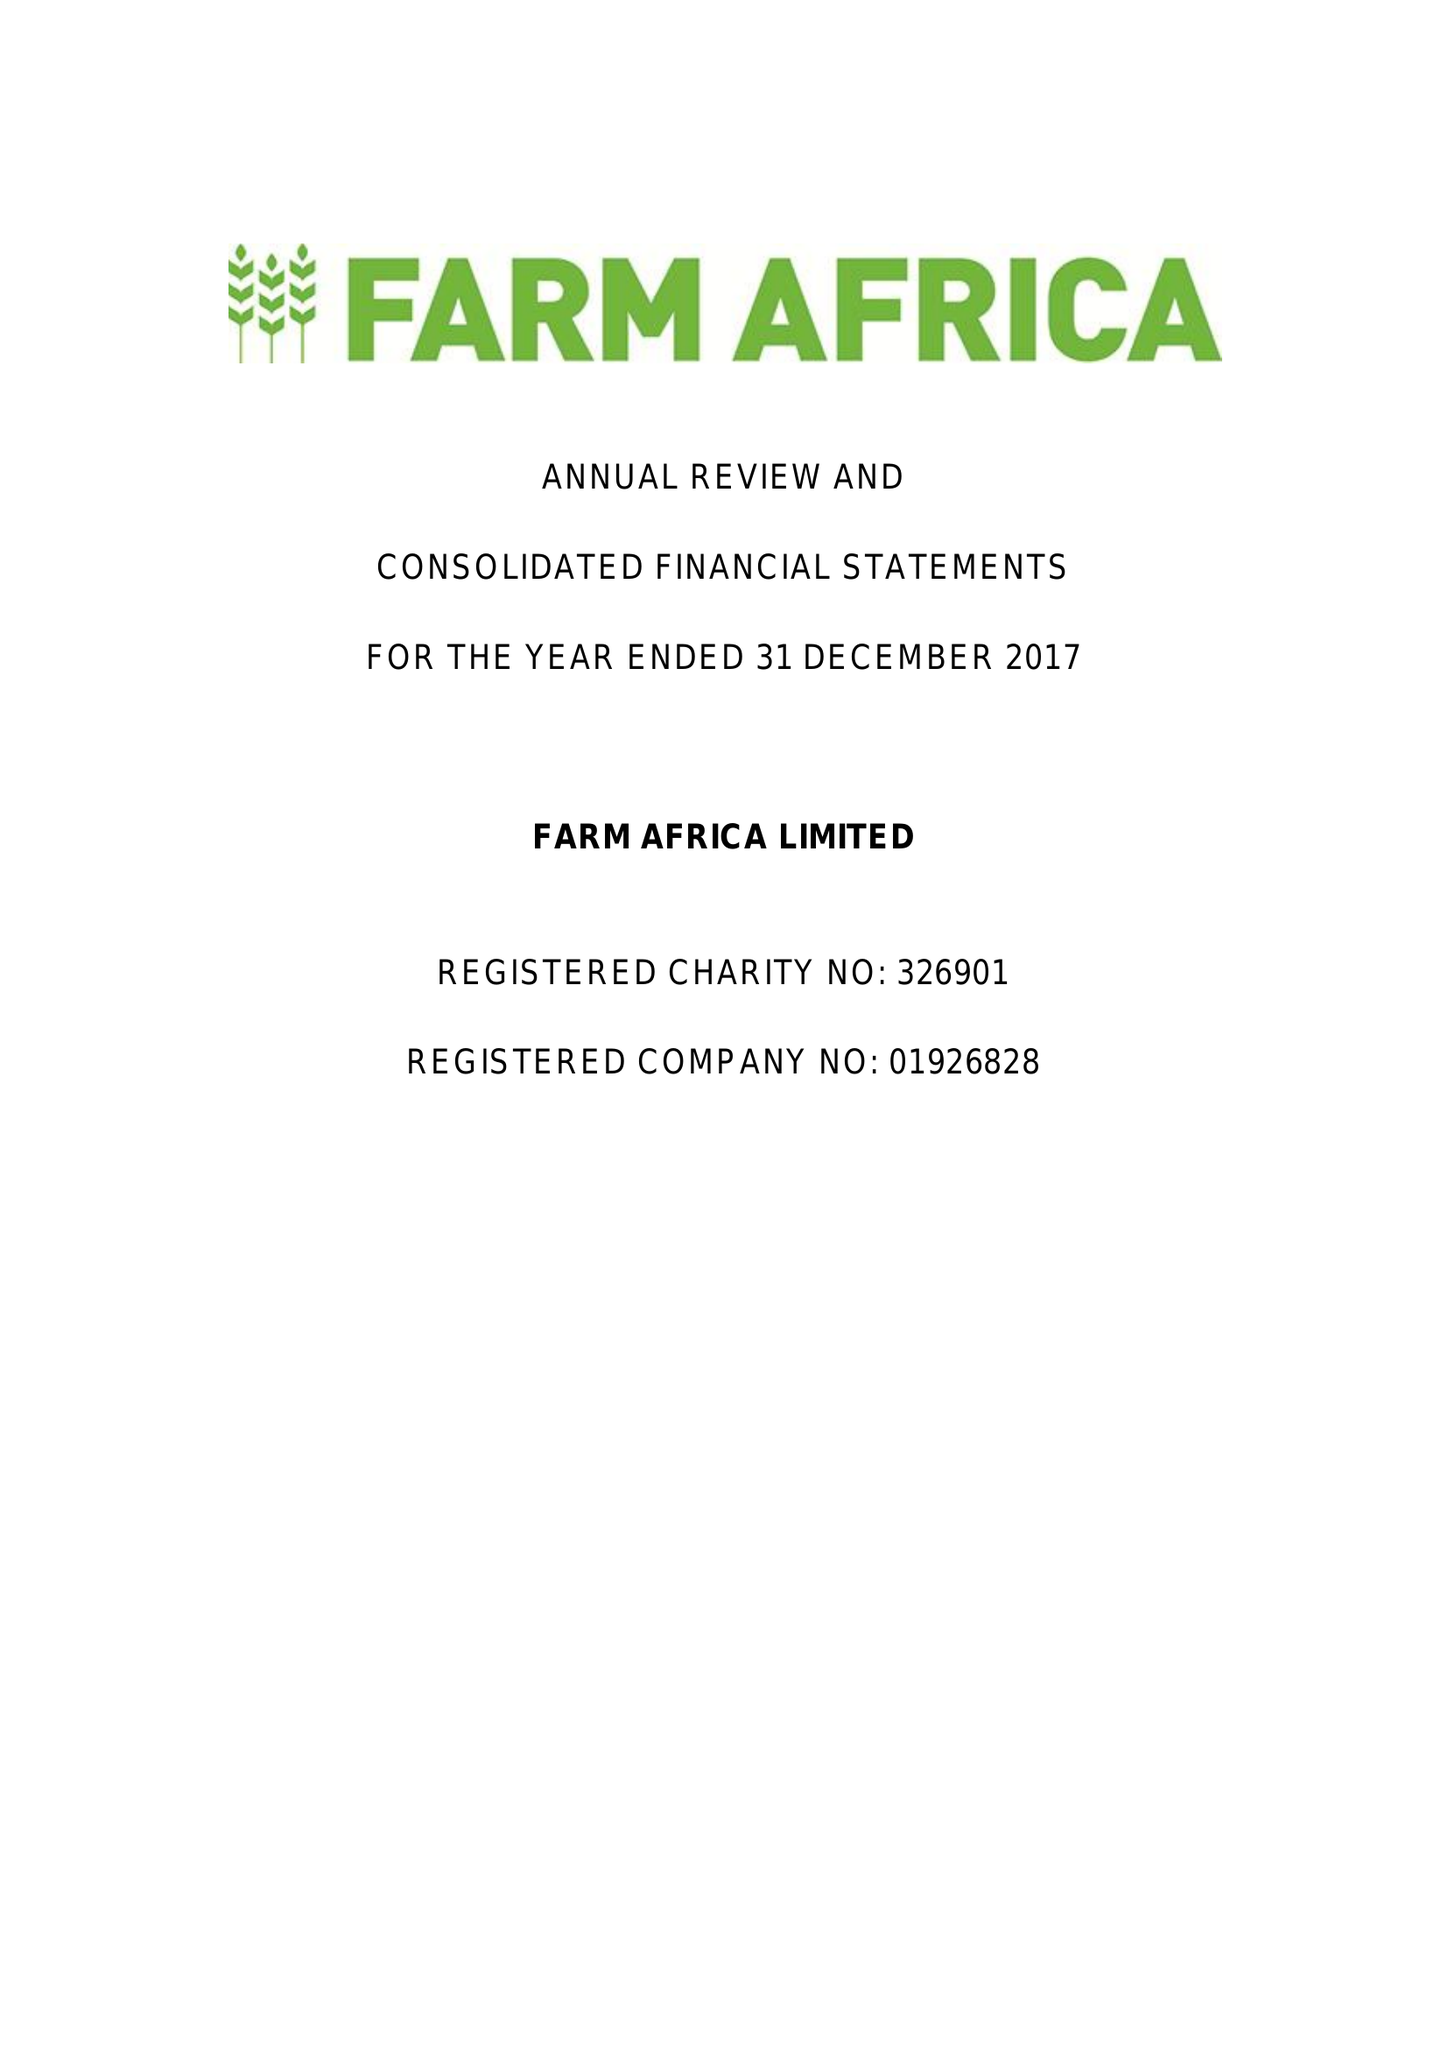What is the value for the address__postcode?
Answer the question using a single word or phrase. EC2Y 5DN 